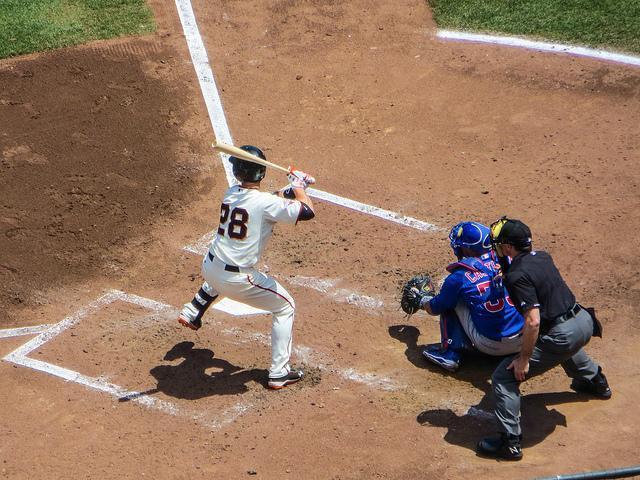How many people are there?
Give a very brief answer. 3. 